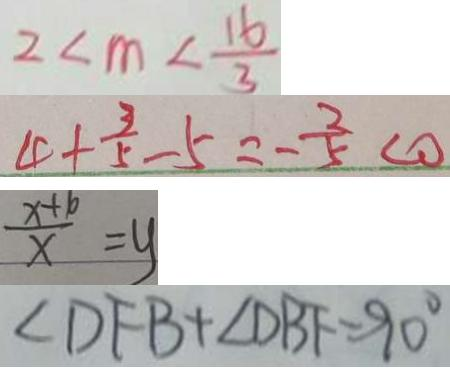Convert formula to latex. <formula><loc_0><loc_0><loc_500><loc_500>2 < m < \frac { 1 6 } { 3 } 
 4 + \frac { 3 } { 5 } - 5 = - \frac { 3 } { 5 } < 0 
 \frac { x + 1 0 } { x } = y 
 \angle D F B + \angle D B F = 9 0 ^ { \circ }</formula> 